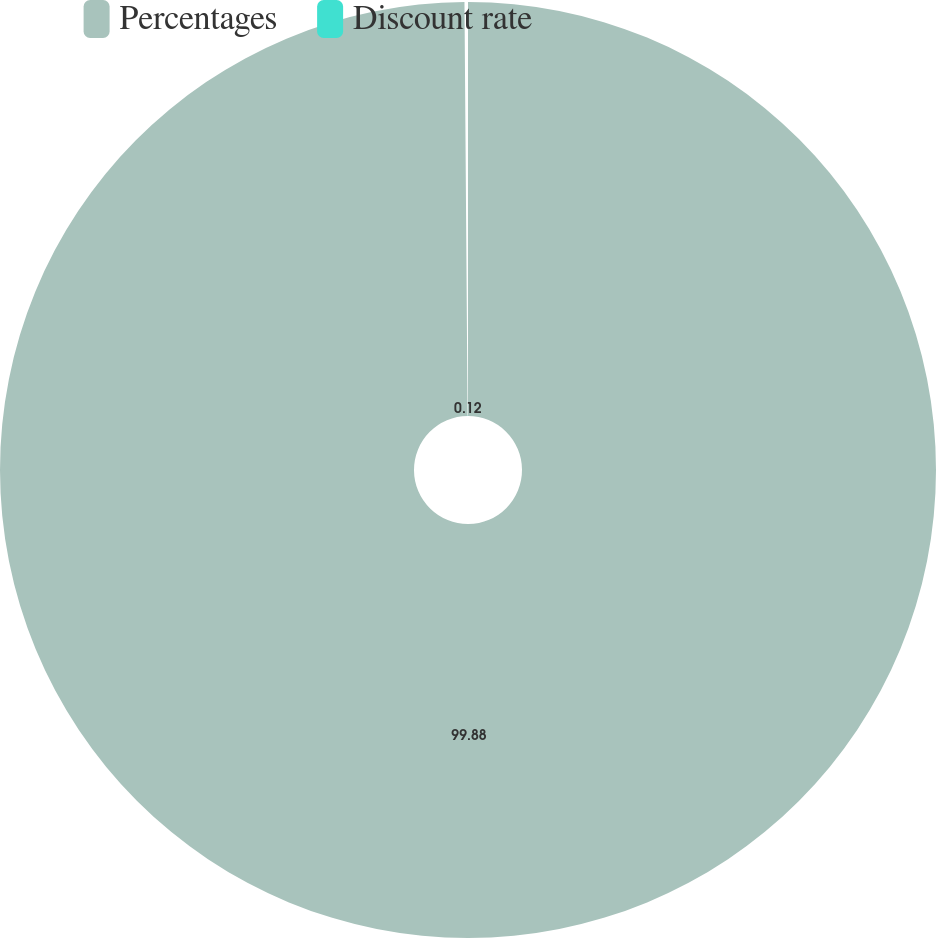Convert chart to OTSL. <chart><loc_0><loc_0><loc_500><loc_500><pie_chart><fcel>Percentages<fcel>Discount rate<nl><fcel>99.88%<fcel>0.12%<nl></chart> 